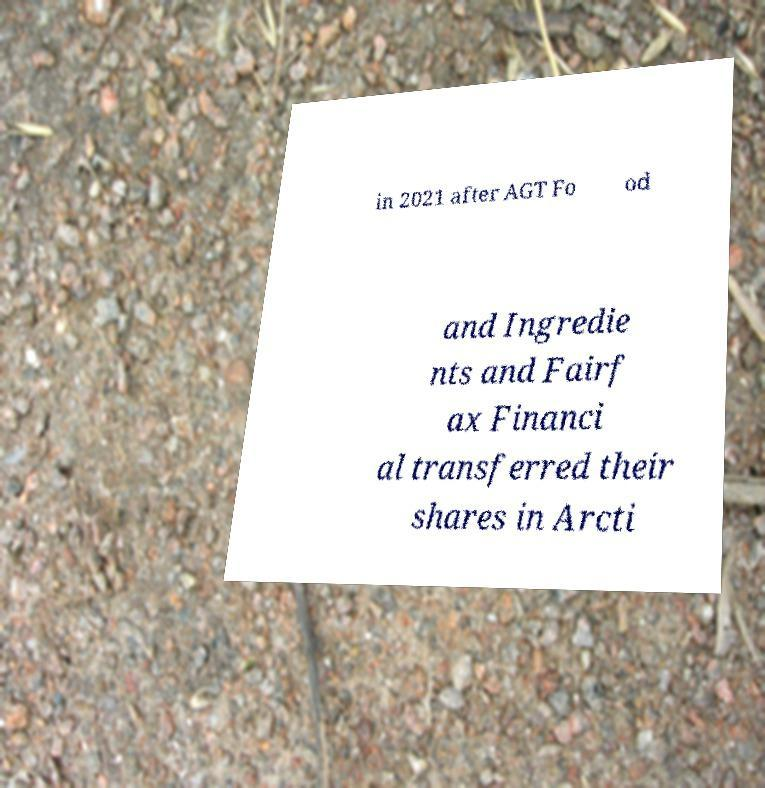I need the written content from this picture converted into text. Can you do that? in 2021 after AGT Fo od and Ingredie nts and Fairf ax Financi al transferred their shares in Arcti 